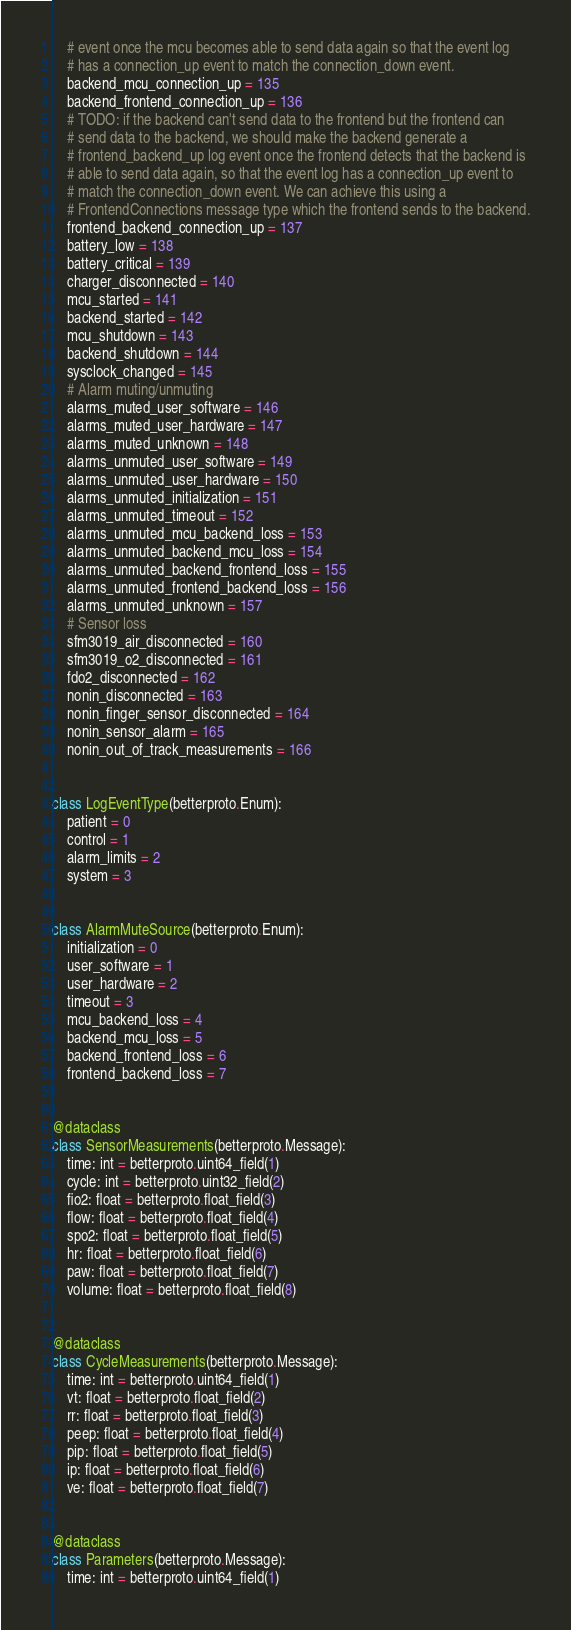<code> <loc_0><loc_0><loc_500><loc_500><_Python_>    # event once the mcu becomes able to send data again so that the event log
    # has a connection_up event to match the connection_down event.
    backend_mcu_connection_up = 135
    backend_frontend_connection_up = 136
    # TODO: if the backend can't send data to the frontend but the frontend can
    # send data to the backend, we should make the backend generate a
    # frontend_backend_up log event once the frontend detects that the backend is
    # able to send data again, so that the event log has a connection_up event to
    # match the connection_down event. We can achieve this using a
    # FrontendConnections message type which the frontend sends to the backend.
    frontend_backend_connection_up = 137
    battery_low = 138
    battery_critical = 139
    charger_disconnected = 140
    mcu_started = 141
    backend_started = 142
    mcu_shutdown = 143
    backend_shutdown = 144
    sysclock_changed = 145
    # Alarm muting/unmuting
    alarms_muted_user_software = 146
    alarms_muted_user_hardware = 147
    alarms_muted_unknown = 148
    alarms_unmuted_user_software = 149
    alarms_unmuted_user_hardware = 150
    alarms_unmuted_initialization = 151
    alarms_unmuted_timeout = 152
    alarms_unmuted_mcu_backend_loss = 153
    alarms_unmuted_backend_mcu_loss = 154
    alarms_unmuted_backend_frontend_loss = 155
    alarms_unmuted_frontend_backend_loss = 156
    alarms_unmuted_unknown = 157
    # Sensor loss
    sfm3019_air_disconnected = 160
    sfm3019_o2_disconnected = 161
    fdo2_disconnected = 162
    nonin_disconnected = 163
    nonin_finger_sensor_disconnected = 164
    nonin_sensor_alarm = 165
    nonin_out_of_track_measurements = 166


class LogEventType(betterproto.Enum):
    patient = 0
    control = 1
    alarm_limits = 2
    system = 3


class AlarmMuteSource(betterproto.Enum):
    initialization = 0
    user_software = 1
    user_hardware = 2
    timeout = 3
    mcu_backend_loss = 4
    backend_mcu_loss = 5
    backend_frontend_loss = 6
    frontend_backend_loss = 7


@dataclass
class SensorMeasurements(betterproto.Message):
    time: int = betterproto.uint64_field(1)
    cycle: int = betterproto.uint32_field(2)
    fio2: float = betterproto.float_field(3)
    flow: float = betterproto.float_field(4)
    spo2: float = betterproto.float_field(5)
    hr: float = betterproto.float_field(6)
    paw: float = betterproto.float_field(7)
    volume: float = betterproto.float_field(8)


@dataclass
class CycleMeasurements(betterproto.Message):
    time: int = betterproto.uint64_field(1)
    vt: float = betterproto.float_field(2)
    rr: float = betterproto.float_field(3)
    peep: float = betterproto.float_field(4)
    pip: float = betterproto.float_field(5)
    ip: float = betterproto.float_field(6)
    ve: float = betterproto.float_field(7)


@dataclass
class Parameters(betterproto.Message):
    time: int = betterproto.uint64_field(1)</code> 